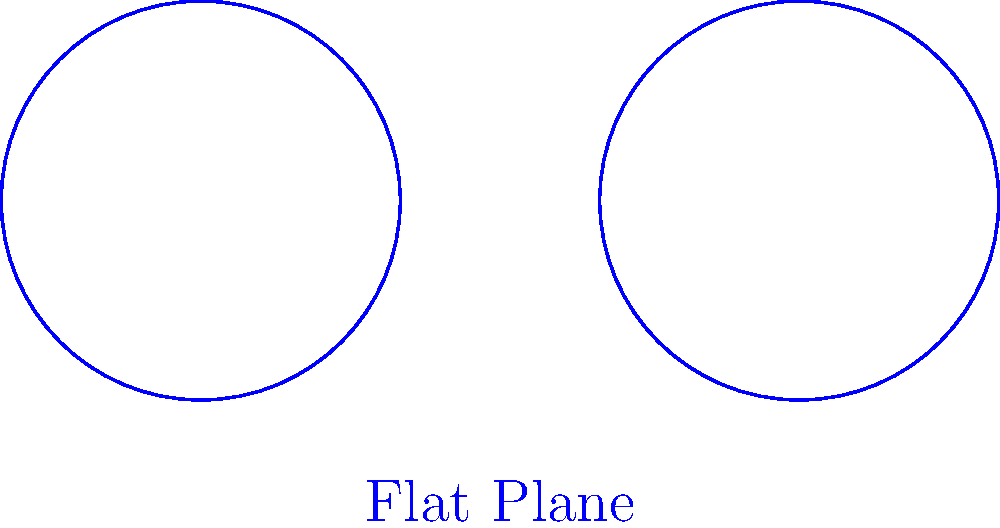In the context of providing equitable healthcare, consider two identical circular examination rooms: one on a flat surface (representing a traditional hospital) and one on the surface of a large sphere (representing a global health initiative). If both rooms have a radius of 5 meters, how does the area of the room on the sphere compare to the area of the room on the flat surface? Assume the sphere has a radius of 6371 km (approximately Earth's radius). Let's approach this step-by-step:

1) Area of a circle on a flat surface:
   $$A_{flat} = \pi r^2 = \pi (5\text{ m})^2 = 25\pi\text{ m}^2$$

2) Area of a circle on a sphere:
   The formula for the area of a circle on a sphere is:
   $$A_{sphere} = 2\pi R^2 (1 - \cos(\frac{r}{R}))$$
   Where $R$ is the radius of the sphere and $r$ is the radius of the circle.

3) Convert our values to kilometers for consistency:
   $r = 5\text{ m} = 0.005\text{ km}$
   $R = 6371\text{ km}$

4) Plug these values into the sphere formula:
   $$A_{sphere} = 2\pi (6371\text{ km})^2 (1 - \cos(\frac{0.005\text{ km}}{6371\text{ km}}))$$

5) Simplify:
   $$A_{sphere} \approx 25\pi\text{ m}^2 - 0.000000082\text{ m}^2$$

6) Compare:
   The difference is extremely small, approximately 0.000000082 m^2.

7) Calculate the ratio:
   $$\frac{A_{sphere}}{A_{flat}} \approx 0.999999997$$

This means the area on the sphere is about 0.0000003% smaller than on the flat surface.
Answer: The area on the sphere is approximately 0.0000003% smaller than on the flat surface, effectively identical for practical healthcare purposes. 